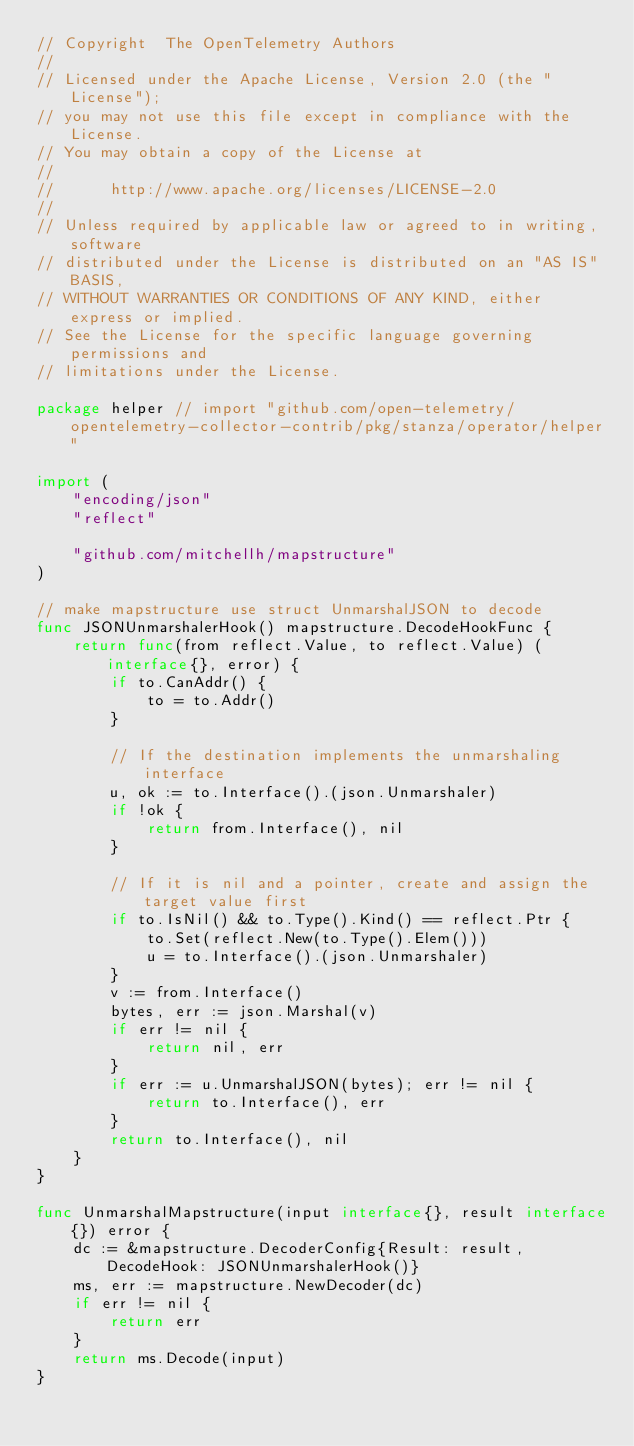<code> <loc_0><loc_0><loc_500><loc_500><_Go_>// Copyright  The OpenTelemetry Authors
//
// Licensed under the Apache License, Version 2.0 (the "License");
// you may not use this file except in compliance with the License.
// You may obtain a copy of the License at
//
//      http://www.apache.org/licenses/LICENSE-2.0
//
// Unless required by applicable law or agreed to in writing, software
// distributed under the License is distributed on an "AS IS" BASIS,
// WITHOUT WARRANTIES OR CONDITIONS OF ANY KIND, either express or implied.
// See the License for the specific language governing permissions and
// limitations under the License.

package helper // import "github.com/open-telemetry/opentelemetry-collector-contrib/pkg/stanza/operator/helper"

import (
	"encoding/json"
	"reflect"

	"github.com/mitchellh/mapstructure"
)

// make mapstructure use struct UnmarshalJSON to decode
func JSONUnmarshalerHook() mapstructure.DecodeHookFunc {
	return func(from reflect.Value, to reflect.Value) (interface{}, error) {
		if to.CanAddr() {
			to = to.Addr()
		}

		// If the destination implements the unmarshaling interface
		u, ok := to.Interface().(json.Unmarshaler)
		if !ok {
			return from.Interface(), nil
		}

		// If it is nil and a pointer, create and assign the target value first
		if to.IsNil() && to.Type().Kind() == reflect.Ptr {
			to.Set(reflect.New(to.Type().Elem()))
			u = to.Interface().(json.Unmarshaler)
		}
		v := from.Interface()
		bytes, err := json.Marshal(v)
		if err != nil {
			return nil, err
		}
		if err := u.UnmarshalJSON(bytes); err != nil {
			return to.Interface(), err
		}
		return to.Interface(), nil
	}
}

func UnmarshalMapstructure(input interface{}, result interface{}) error {
	dc := &mapstructure.DecoderConfig{Result: result, DecodeHook: JSONUnmarshalerHook()}
	ms, err := mapstructure.NewDecoder(dc)
	if err != nil {
		return err
	}
	return ms.Decode(input)
}
</code> 